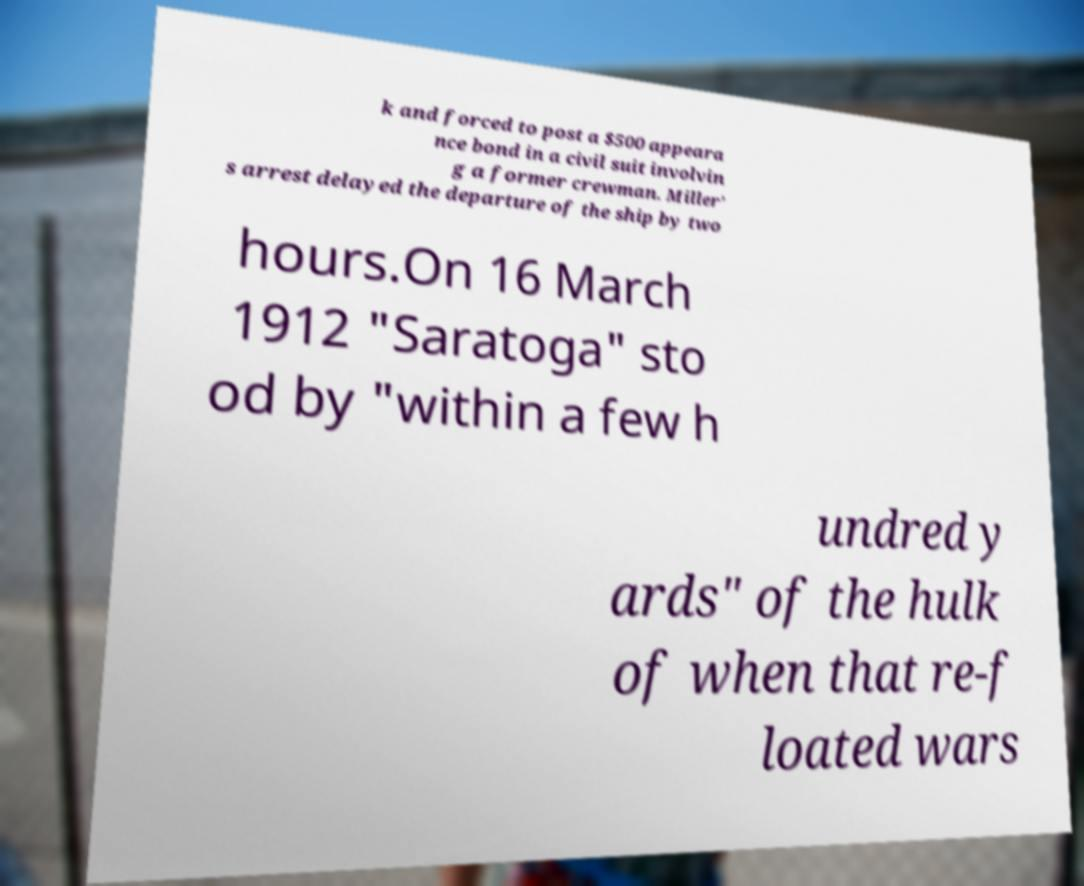Please identify and transcribe the text found in this image. k and forced to post a $500 appeara nce bond in a civil suit involvin g a former crewman. Miller’ s arrest delayed the departure of the ship by two hours.On 16 March 1912 "Saratoga" sto od by "within a few h undred y ards" of the hulk of when that re-f loated wars 